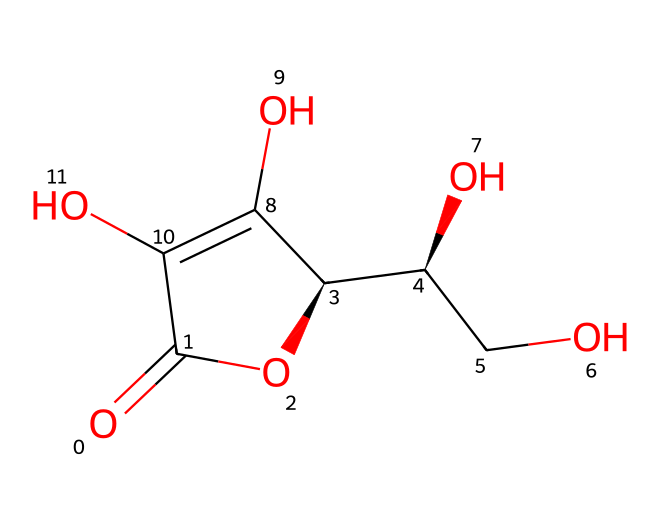What is the name of this chemical? The chemical is vitamin C, which is known for its antioxidant properties and is commonly found in citrus fruits. The structure features specific functional groups that are characteristic of vitamin C.
Answer: vitamin C How many carbon atoms are in this structure? By examining the SMILES representation, there are six carbon atoms present in the overall structure of vitamin C, which can be counted directly from the structure itself.
Answer: six What is the functionality of this chemical? Vitamin C functions primarily as an antioxidant and is crucial for collagen synthesis, impacting skin health and immune function. This role is attributed to its specific molecular structure, which allows it to donate electrons.
Answer: antioxidant Are there any hydroxyl (-OH) groups in the structure? The SMILES representation indicates the presence of multiple -OH (hydroxyl) groups, which are essential for the solubility and reactivity of vitamin C, as seen directly in the structure.
Answer: yes What type of bonds are present in this chemical structure? The chemical structure represents a combination of single and double bonds. The double bond is specifically found between the carbon atoms, while single bonds connect the other constituent atoms. This can be identified through the connections in the SMILES notation.
Answer: single and double bonds How does the presence of hydroxyl groups affect its solubility? The numerous hydroxyl groups (–OH) increase the polarity of vitamin C, making it water-soluble. This solubility is due to hydrogen bonding that can occur between the hydroxyl groups and water molecules, enhancing the compound's interaction with water.
Answer: increases solubility 